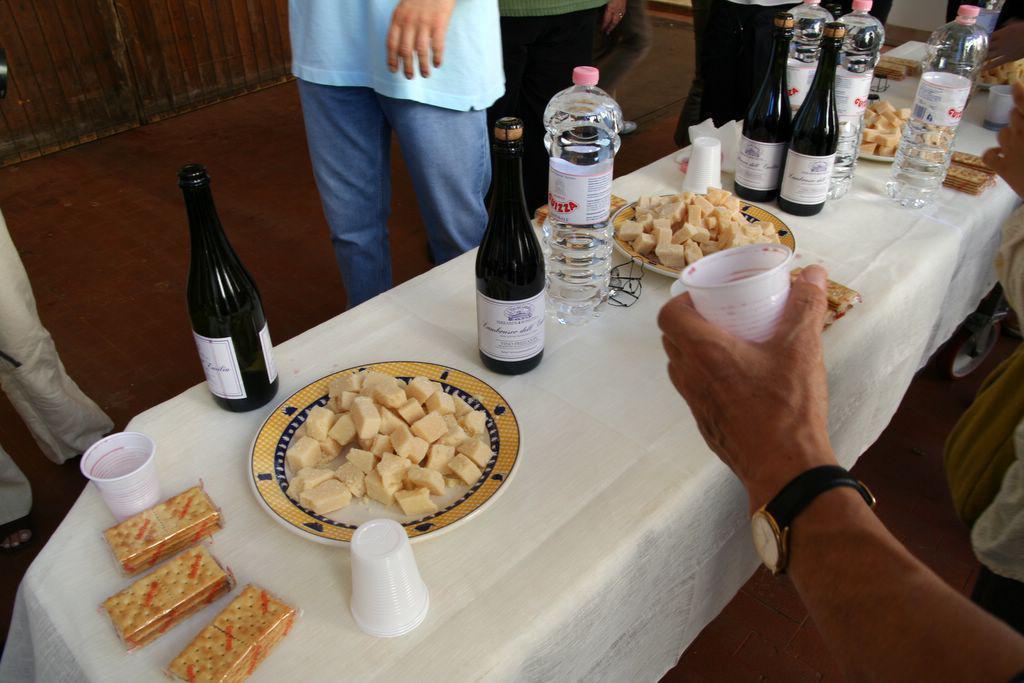Can you describe this image briefly? In the picture there is big table. On the table a white cloth is spread. On the table there are glasses, biscuit packets, food in plates, water bottles and wine bottles. On the two sides of the table people are standing and walking. There is a hand of a person at the below right corner is holding a glass and wearing a watch.  